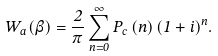<formula> <loc_0><loc_0><loc_500><loc_500>W _ { a } ( \beta ) = \frac { 2 } { \pi } \sum _ { n = 0 } ^ { \infty } P _ { c } \left ( n \right ) ( 1 + i ) ^ { n } .</formula> 